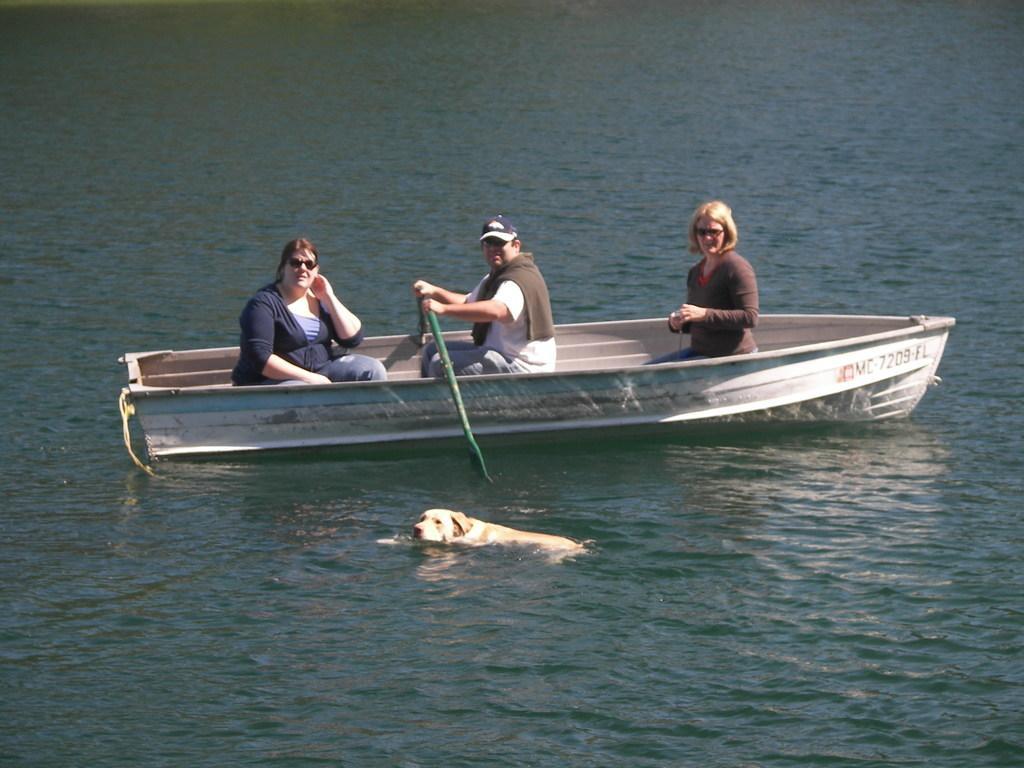In one or two sentences, can you explain what this image depicts? In this picture we can observe a boat floating on the water. There are three members sitting in the boat. We can observe a cream colored dog swimming in the water. In the background we can observe a river. 